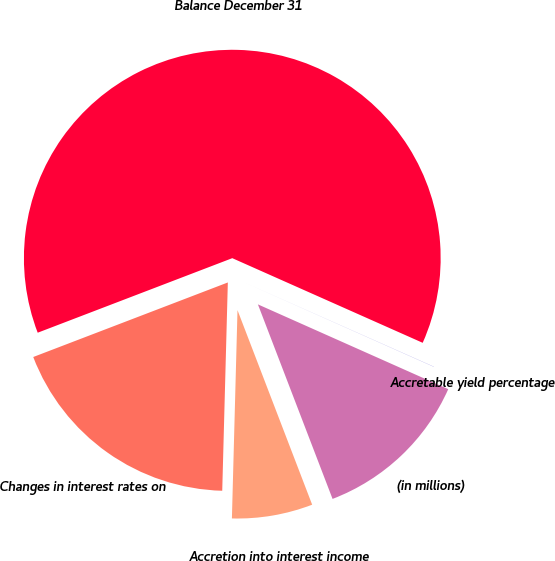Convert chart. <chart><loc_0><loc_0><loc_500><loc_500><pie_chart><fcel>(in millions)<fcel>Accretion into interest income<fcel>Changes in interest rates on<fcel>Balance December 31<fcel>Accretable yield percentage<nl><fcel>12.5%<fcel>6.26%<fcel>18.75%<fcel>62.48%<fcel>0.01%<nl></chart> 